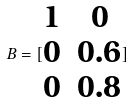<formula> <loc_0><loc_0><loc_500><loc_500>B = [ \begin{matrix} 1 & 0 \\ 0 & 0 . 6 \\ 0 & 0 . 8 \end{matrix} ]</formula> 